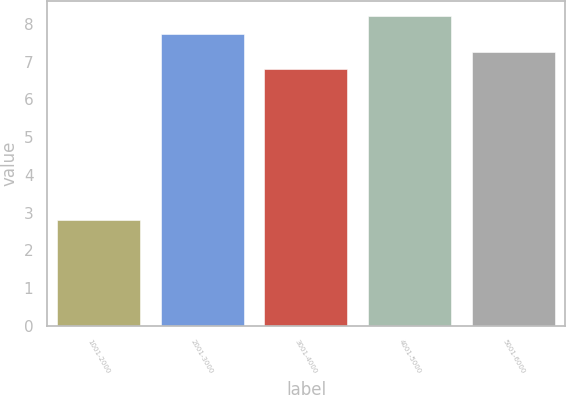Convert chart. <chart><loc_0><loc_0><loc_500><loc_500><bar_chart><fcel>1001-2000<fcel>2001-3000<fcel>3001-4000<fcel>4001-5000<fcel>5001-6000<nl><fcel>2.8<fcel>7.74<fcel>6.8<fcel>8.21<fcel>7.27<nl></chart> 